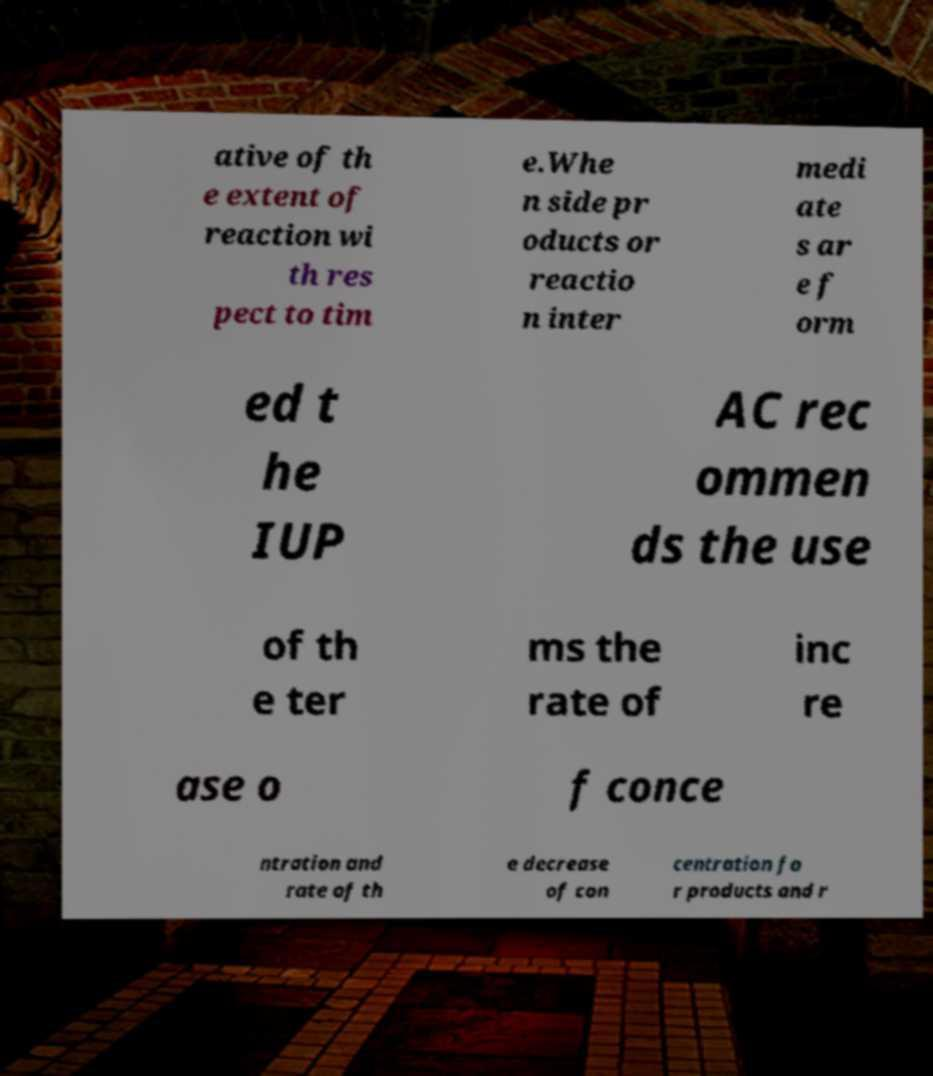Can you read and provide the text displayed in the image?This photo seems to have some interesting text. Can you extract and type it out for me? ative of th e extent of reaction wi th res pect to tim e.Whe n side pr oducts or reactio n inter medi ate s ar e f orm ed t he IUP AC rec ommen ds the use of th e ter ms the rate of inc re ase o f conce ntration and rate of th e decrease of con centration fo r products and r 